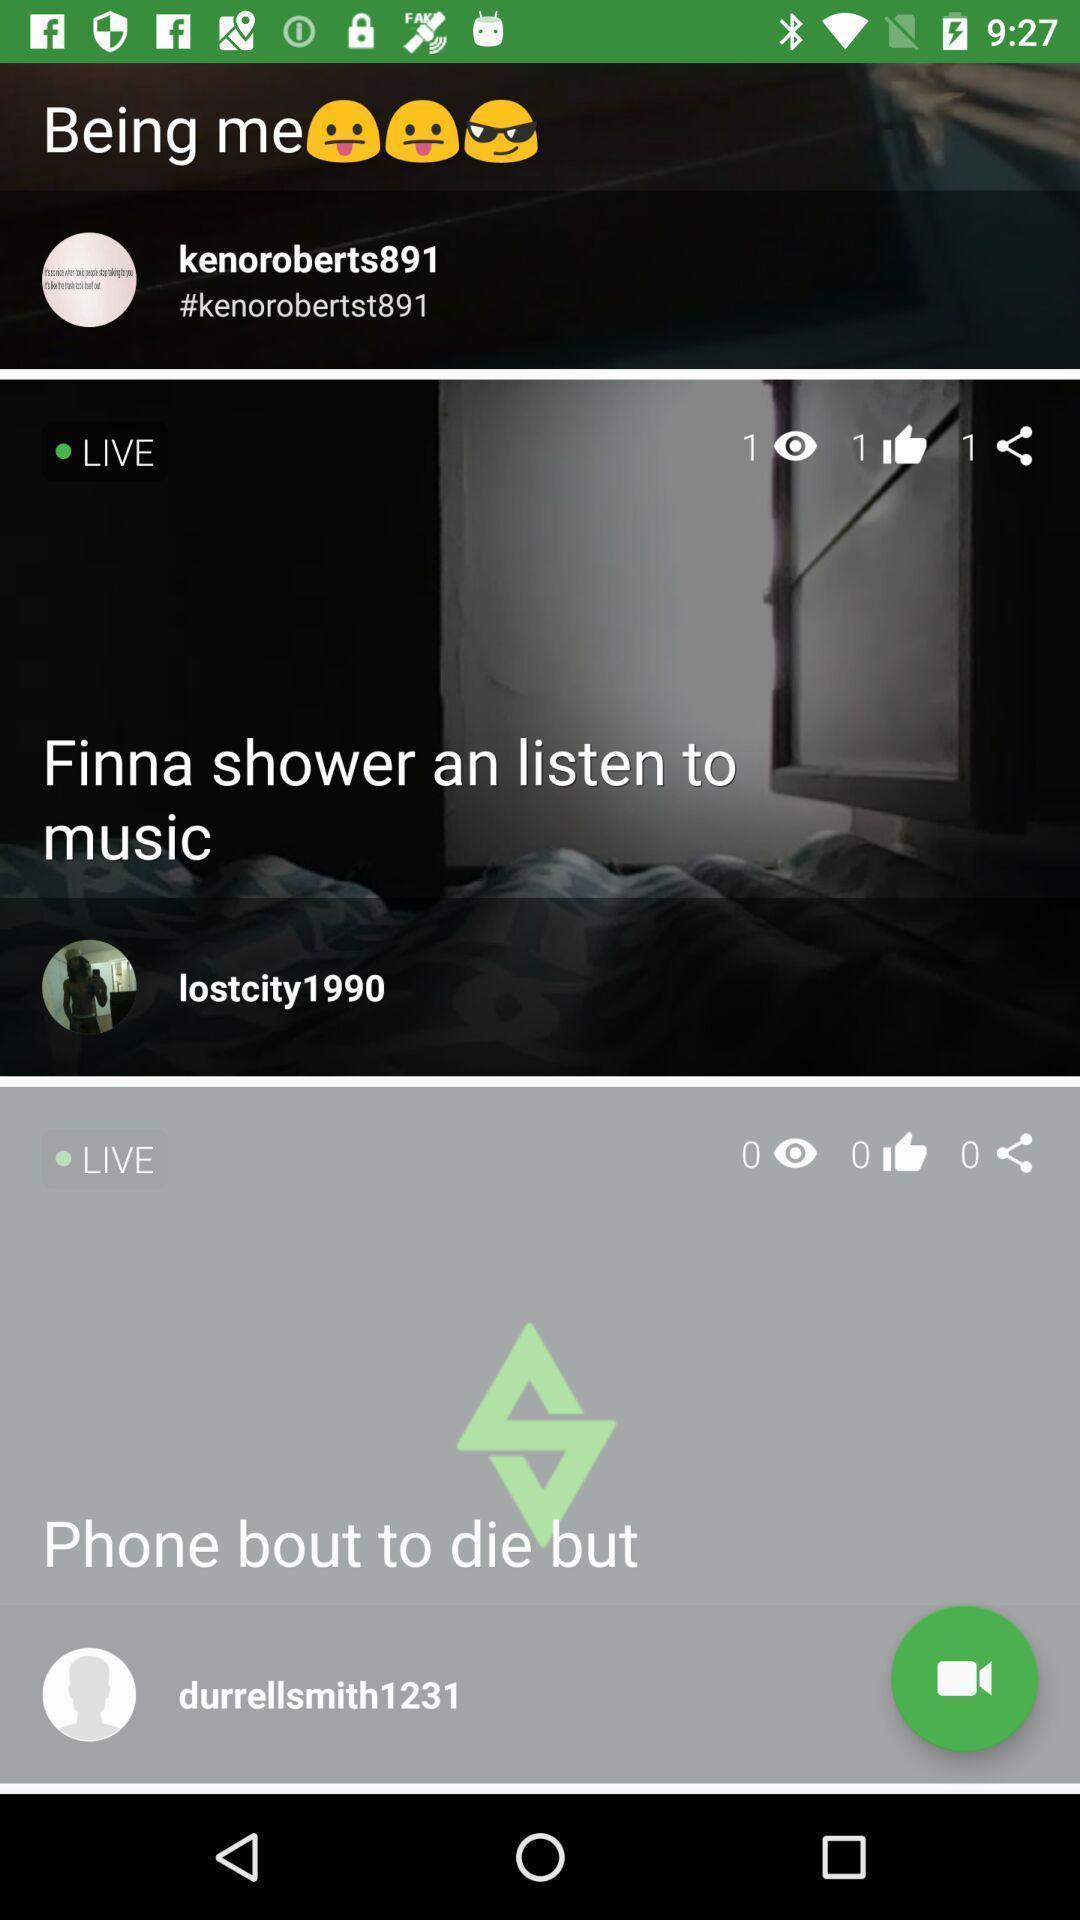Explain the elements present in this screenshot. Screen showing live videos. 